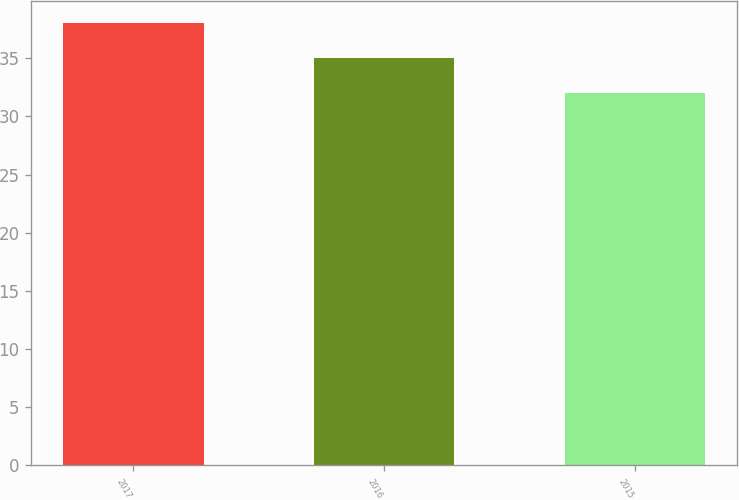<chart> <loc_0><loc_0><loc_500><loc_500><bar_chart><fcel>2017<fcel>2016<fcel>2015<nl><fcel>38<fcel>35<fcel>32<nl></chart> 